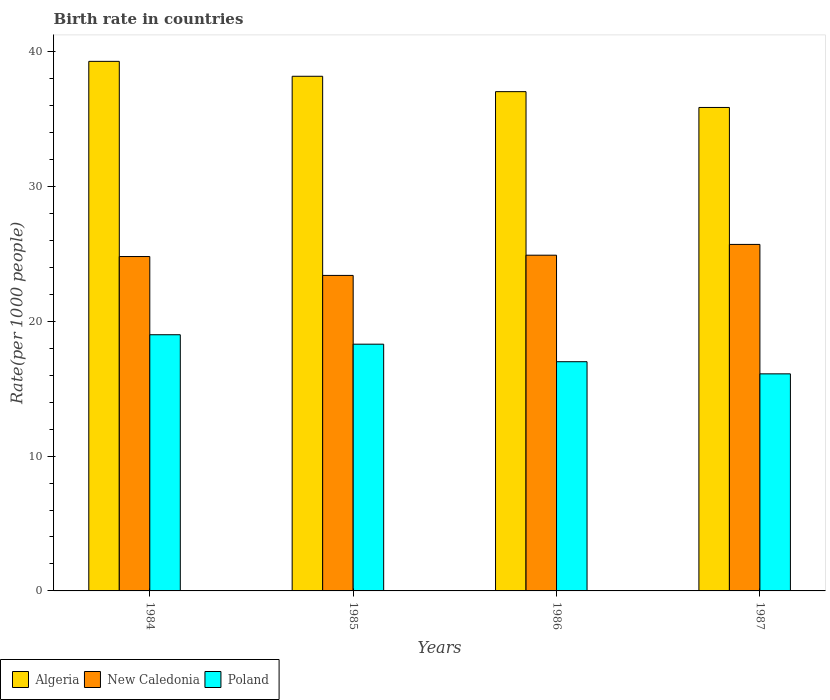Are the number of bars per tick equal to the number of legend labels?
Make the answer very short. Yes. Are the number of bars on each tick of the X-axis equal?
Your answer should be compact. Yes. What is the label of the 2nd group of bars from the left?
Ensure brevity in your answer.  1985. Across all years, what is the maximum birth rate in New Caledonia?
Keep it short and to the point. 25.7. Across all years, what is the minimum birth rate in New Caledonia?
Give a very brief answer. 23.4. In which year was the birth rate in Poland minimum?
Provide a succinct answer. 1987. What is the total birth rate in Algeria in the graph?
Your answer should be compact. 150.33. What is the difference between the birth rate in Poland in 1985 and that in 1987?
Your answer should be very brief. 2.2. What is the difference between the birth rate in Algeria in 1987 and the birth rate in Poland in 1984?
Offer a terse response. 16.86. What is the average birth rate in New Caledonia per year?
Offer a terse response. 24.7. In the year 1985, what is the difference between the birth rate in New Caledonia and birth rate in Poland?
Make the answer very short. 5.1. What is the ratio of the birth rate in New Caledonia in 1984 to that in 1985?
Ensure brevity in your answer.  1.06. Is the birth rate in New Caledonia in 1984 less than that in 1986?
Your answer should be compact. Yes. What is the difference between the highest and the second highest birth rate in Poland?
Offer a very short reply. 0.7. What is the difference between the highest and the lowest birth rate in New Caledonia?
Your answer should be very brief. 2.3. In how many years, is the birth rate in Algeria greater than the average birth rate in Algeria taken over all years?
Your answer should be compact. 2. Is the sum of the birth rate in New Caledonia in 1984 and 1987 greater than the maximum birth rate in Poland across all years?
Make the answer very short. Yes. What does the 1st bar from the left in 1985 represents?
Offer a very short reply. Algeria. What does the 1st bar from the right in 1986 represents?
Your answer should be compact. Poland. How many bars are there?
Provide a short and direct response. 12. Are all the bars in the graph horizontal?
Ensure brevity in your answer.  No. Does the graph contain grids?
Your response must be concise. No. Where does the legend appear in the graph?
Give a very brief answer. Bottom left. How are the legend labels stacked?
Your response must be concise. Horizontal. What is the title of the graph?
Your answer should be compact. Birth rate in countries. Does "Indonesia" appear as one of the legend labels in the graph?
Ensure brevity in your answer.  No. What is the label or title of the Y-axis?
Offer a terse response. Rate(per 1000 people). What is the Rate(per 1000 people) of Algeria in 1984?
Make the answer very short. 39.28. What is the Rate(per 1000 people) in New Caledonia in 1984?
Your answer should be compact. 24.8. What is the Rate(per 1000 people) of Algeria in 1985?
Give a very brief answer. 38.17. What is the Rate(per 1000 people) in New Caledonia in 1985?
Give a very brief answer. 23.4. What is the Rate(per 1000 people) in Algeria in 1986?
Your answer should be very brief. 37.03. What is the Rate(per 1000 people) of New Caledonia in 1986?
Provide a short and direct response. 24.9. What is the Rate(per 1000 people) of Algeria in 1987?
Your answer should be very brief. 35.86. What is the Rate(per 1000 people) of New Caledonia in 1987?
Keep it short and to the point. 25.7. What is the Rate(per 1000 people) in Poland in 1987?
Your answer should be very brief. 16.1. Across all years, what is the maximum Rate(per 1000 people) of Algeria?
Your answer should be compact. 39.28. Across all years, what is the maximum Rate(per 1000 people) of New Caledonia?
Offer a terse response. 25.7. Across all years, what is the maximum Rate(per 1000 people) of Poland?
Your answer should be very brief. 19. Across all years, what is the minimum Rate(per 1000 people) in Algeria?
Ensure brevity in your answer.  35.86. Across all years, what is the minimum Rate(per 1000 people) in New Caledonia?
Give a very brief answer. 23.4. What is the total Rate(per 1000 people) in Algeria in the graph?
Offer a very short reply. 150.33. What is the total Rate(per 1000 people) of New Caledonia in the graph?
Your answer should be very brief. 98.8. What is the total Rate(per 1000 people) in Poland in the graph?
Keep it short and to the point. 70.4. What is the difference between the Rate(per 1000 people) of Algeria in 1984 and that in 1985?
Offer a very short reply. 1.11. What is the difference between the Rate(per 1000 people) in Poland in 1984 and that in 1985?
Your answer should be compact. 0.7. What is the difference between the Rate(per 1000 people) in Algeria in 1984 and that in 1986?
Provide a short and direct response. 2.25. What is the difference between the Rate(per 1000 people) of New Caledonia in 1984 and that in 1986?
Keep it short and to the point. -0.1. What is the difference between the Rate(per 1000 people) of Poland in 1984 and that in 1986?
Your answer should be compact. 2. What is the difference between the Rate(per 1000 people) in Algeria in 1984 and that in 1987?
Make the answer very short. 3.42. What is the difference between the Rate(per 1000 people) of Poland in 1984 and that in 1987?
Make the answer very short. 2.9. What is the difference between the Rate(per 1000 people) of Algeria in 1985 and that in 1986?
Your answer should be very brief. 1.14. What is the difference between the Rate(per 1000 people) in Algeria in 1985 and that in 1987?
Offer a very short reply. 2.31. What is the difference between the Rate(per 1000 people) of New Caledonia in 1985 and that in 1987?
Give a very brief answer. -2.3. What is the difference between the Rate(per 1000 people) in Algeria in 1986 and that in 1987?
Your response must be concise. 1.17. What is the difference between the Rate(per 1000 people) in Poland in 1986 and that in 1987?
Offer a very short reply. 0.9. What is the difference between the Rate(per 1000 people) of Algeria in 1984 and the Rate(per 1000 people) of New Caledonia in 1985?
Your response must be concise. 15.88. What is the difference between the Rate(per 1000 people) of Algeria in 1984 and the Rate(per 1000 people) of Poland in 1985?
Your answer should be compact. 20.98. What is the difference between the Rate(per 1000 people) of Algeria in 1984 and the Rate(per 1000 people) of New Caledonia in 1986?
Offer a very short reply. 14.38. What is the difference between the Rate(per 1000 people) in Algeria in 1984 and the Rate(per 1000 people) in Poland in 1986?
Provide a succinct answer. 22.28. What is the difference between the Rate(per 1000 people) in Algeria in 1984 and the Rate(per 1000 people) in New Caledonia in 1987?
Provide a short and direct response. 13.58. What is the difference between the Rate(per 1000 people) in Algeria in 1984 and the Rate(per 1000 people) in Poland in 1987?
Offer a terse response. 23.18. What is the difference between the Rate(per 1000 people) of Algeria in 1985 and the Rate(per 1000 people) of New Caledonia in 1986?
Your answer should be very brief. 13.27. What is the difference between the Rate(per 1000 people) in Algeria in 1985 and the Rate(per 1000 people) in Poland in 1986?
Your answer should be compact. 21.17. What is the difference between the Rate(per 1000 people) of Algeria in 1985 and the Rate(per 1000 people) of New Caledonia in 1987?
Provide a short and direct response. 12.47. What is the difference between the Rate(per 1000 people) of Algeria in 1985 and the Rate(per 1000 people) of Poland in 1987?
Ensure brevity in your answer.  22.07. What is the difference between the Rate(per 1000 people) in Algeria in 1986 and the Rate(per 1000 people) in New Caledonia in 1987?
Your answer should be very brief. 11.33. What is the difference between the Rate(per 1000 people) of Algeria in 1986 and the Rate(per 1000 people) of Poland in 1987?
Make the answer very short. 20.93. What is the difference between the Rate(per 1000 people) in New Caledonia in 1986 and the Rate(per 1000 people) in Poland in 1987?
Offer a very short reply. 8.8. What is the average Rate(per 1000 people) in Algeria per year?
Offer a terse response. 37.58. What is the average Rate(per 1000 people) of New Caledonia per year?
Offer a very short reply. 24.7. In the year 1984, what is the difference between the Rate(per 1000 people) in Algeria and Rate(per 1000 people) in New Caledonia?
Keep it short and to the point. 14.48. In the year 1984, what is the difference between the Rate(per 1000 people) in Algeria and Rate(per 1000 people) in Poland?
Offer a very short reply. 20.28. In the year 1985, what is the difference between the Rate(per 1000 people) in Algeria and Rate(per 1000 people) in New Caledonia?
Your answer should be compact. 14.77. In the year 1985, what is the difference between the Rate(per 1000 people) in Algeria and Rate(per 1000 people) in Poland?
Give a very brief answer. 19.87. In the year 1985, what is the difference between the Rate(per 1000 people) of New Caledonia and Rate(per 1000 people) of Poland?
Keep it short and to the point. 5.1. In the year 1986, what is the difference between the Rate(per 1000 people) of Algeria and Rate(per 1000 people) of New Caledonia?
Provide a short and direct response. 12.13. In the year 1986, what is the difference between the Rate(per 1000 people) of Algeria and Rate(per 1000 people) of Poland?
Your answer should be very brief. 20.03. In the year 1987, what is the difference between the Rate(per 1000 people) in Algeria and Rate(per 1000 people) in New Caledonia?
Give a very brief answer. 10.16. In the year 1987, what is the difference between the Rate(per 1000 people) of Algeria and Rate(per 1000 people) of Poland?
Offer a terse response. 19.76. What is the ratio of the Rate(per 1000 people) in Algeria in 1984 to that in 1985?
Your answer should be compact. 1.03. What is the ratio of the Rate(per 1000 people) in New Caledonia in 1984 to that in 1985?
Ensure brevity in your answer.  1.06. What is the ratio of the Rate(per 1000 people) in Poland in 1984 to that in 1985?
Your answer should be compact. 1.04. What is the ratio of the Rate(per 1000 people) of Algeria in 1984 to that in 1986?
Provide a short and direct response. 1.06. What is the ratio of the Rate(per 1000 people) of New Caledonia in 1984 to that in 1986?
Your answer should be very brief. 1. What is the ratio of the Rate(per 1000 people) of Poland in 1984 to that in 1986?
Offer a terse response. 1.12. What is the ratio of the Rate(per 1000 people) of Algeria in 1984 to that in 1987?
Provide a short and direct response. 1.1. What is the ratio of the Rate(per 1000 people) in Poland in 1984 to that in 1987?
Your response must be concise. 1.18. What is the ratio of the Rate(per 1000 people) of Algeria in 1985 to that in 1986?
Give a very brief answer. 1.03. What is the ratio of the Rate(per 1000 people) of New Caledonia in 1985 to that in 1986?
Provide a short and direct response. 0.94. What is the ratio of the Rate(per 1000 people) of Poland in 1985 to that in 1986?
Your answer should be compact. 1.08. What is the ratio of the Rate(per 1000 people) of Algeria in 1985 to that in 1987?
Give a very brief answer. 1.06. What is the ratio of the Rate(per 1000 people) in New Caledonia in 1985 to that in 1987?
Give a very brief answer. 0.91. What is the ratio of the Rate(per 1000 people) in Poland in 1985 to that in 1987?
Offer a terse response. 1.14. What is the ratio of the Rate(per 1000 people) of Algeria in 1986 to that in 1987?
Keep it short and to the point. 1.03. What is the ratio of the Rate(per 1000 people) in New Caledonia in 1986 to that in 1987?
Keep it short and to the point. 0.97. What is the ratio of the Rate(per 1000 people) of Poland in 1986 to that in 1987?
Give a very brief answer. 1.06. What is the difference between the highest and the second highest Rate(per 1000 people) of Algeria?
Ensure brevity in your answer.  1.11. What is the difference between the highest and the second highest Rate(per 1000 people) of New Caledonia?
Offer a very short reply. 0.8. What is the difference between the highest and the lowest Rate(per 1000 people) of Algeria?
Your answer should be compact. 3.42. 